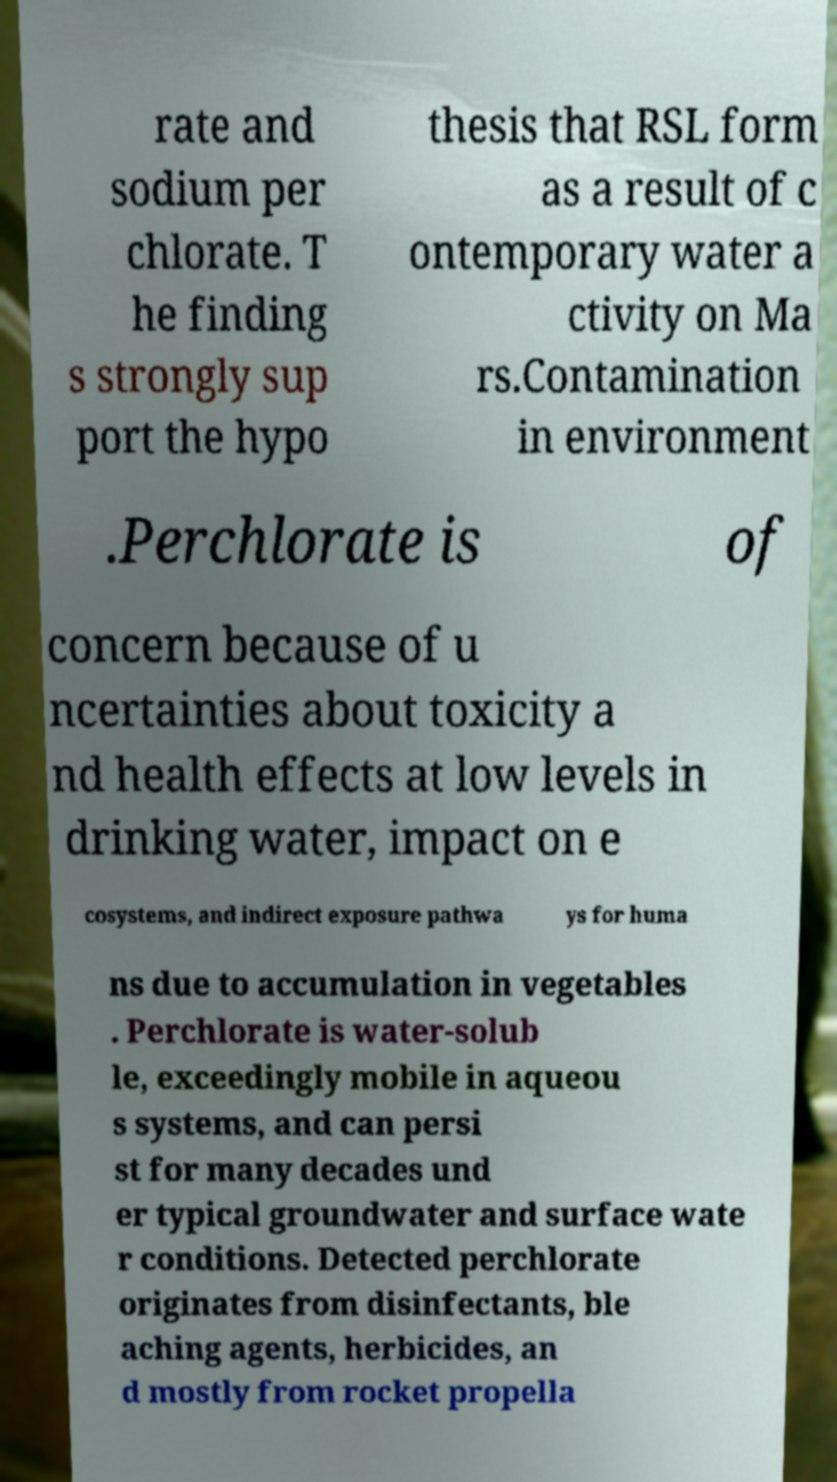For documentation purposes, I need the text within this image transcribed. Could you provide that? rate and sodium per chlorate. T he finding s strongly sup port the hypo thesis that RSL form as a result of c ontemporary water a ctivity on Ma rs.Contamination in environment .Perchlorate is of concern because of u ncertainties about toxicity a nd health effects at low levels in drinking water, impact on e cosystems, and indirect exposure pathwa ys for huma ns due to accumulation in vegetables . Perchlorate is water-solub le, exceedingly mobile in aqueou s systems, and can persi st for many decades und er typical groundwater and surface wate r conditions. Detected perchlorate originates from disinfectants, ble aching agents, herbicides, an d mostly from rocket propella 